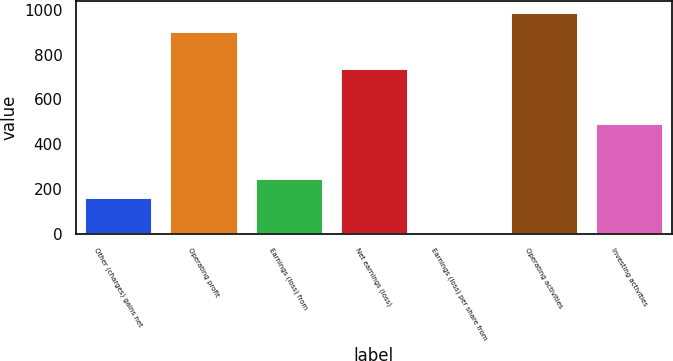<chart> <loc_0><loc_0><loc_500><loc_500><bar_chart><fcel>Other (charges) gains net<fcel>Operating profit<fcel>Earnings (loss) from<fcel>Net earnings (loss)<fcel>Earnings (loss) per share from<fcel>Operating activities<fcel>Investing activities<nl><fcel>166.28<fcel>906.17<fcel>248.49<fcel>741.75<fcel>1.86<fcel>988.38<fcel>495.12<nl></chart> 